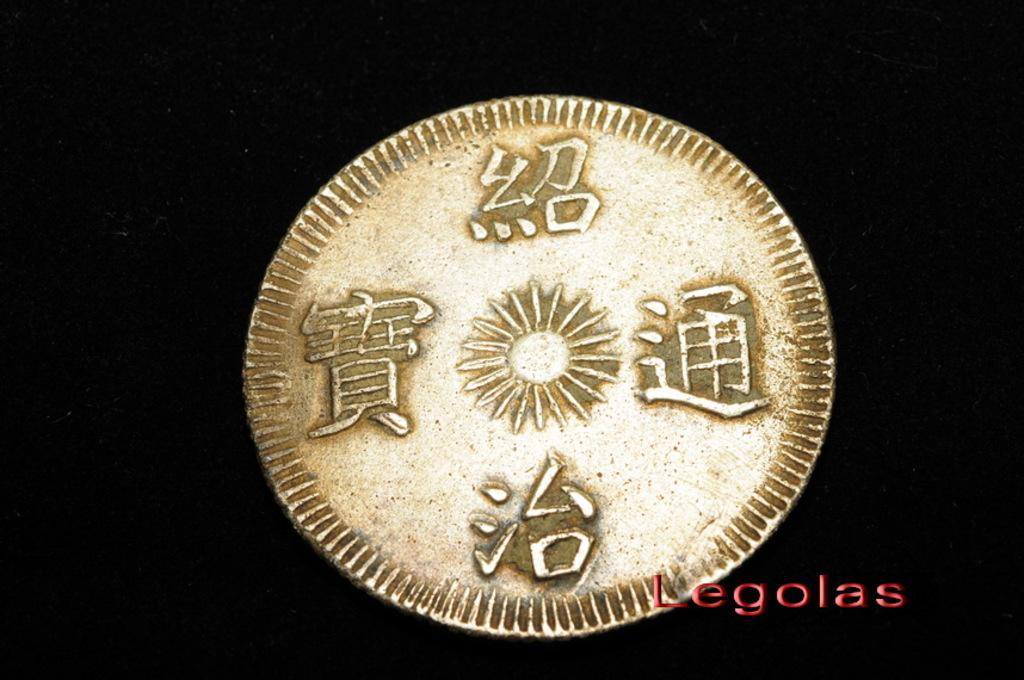What object is the main focus of the image? There is a coin in the image. What is the color of the surface the coin is on? The coin is on a black surface. What can be found on the coin itself? There are symbols on the coin. Where is the text located in the image? There is text on the right side bottom of the image. Can you see the ocean in the background of the image? There is no ocean present in the image; it only features a coin on a black surface. What type of pen is being used to write the text on the coin? There is no pen visible in the image, and the text appears to be part of the coin's design rather than written on it. 